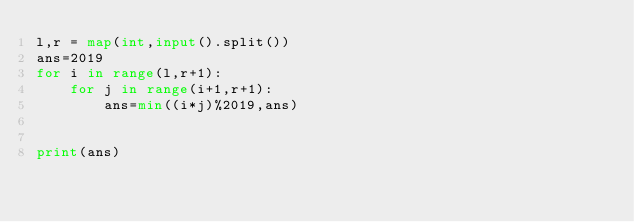Convert code to text. <code><loc_0><loc_0><loc_500><loc_500><_Python_>l,r = map(int,input().split())
ans=2019
for i in range(l,r+1):
    for j in range(i+1,r+1):
        ans=min((i*j)%2019,ans)
        
        
print(ans)</code> 